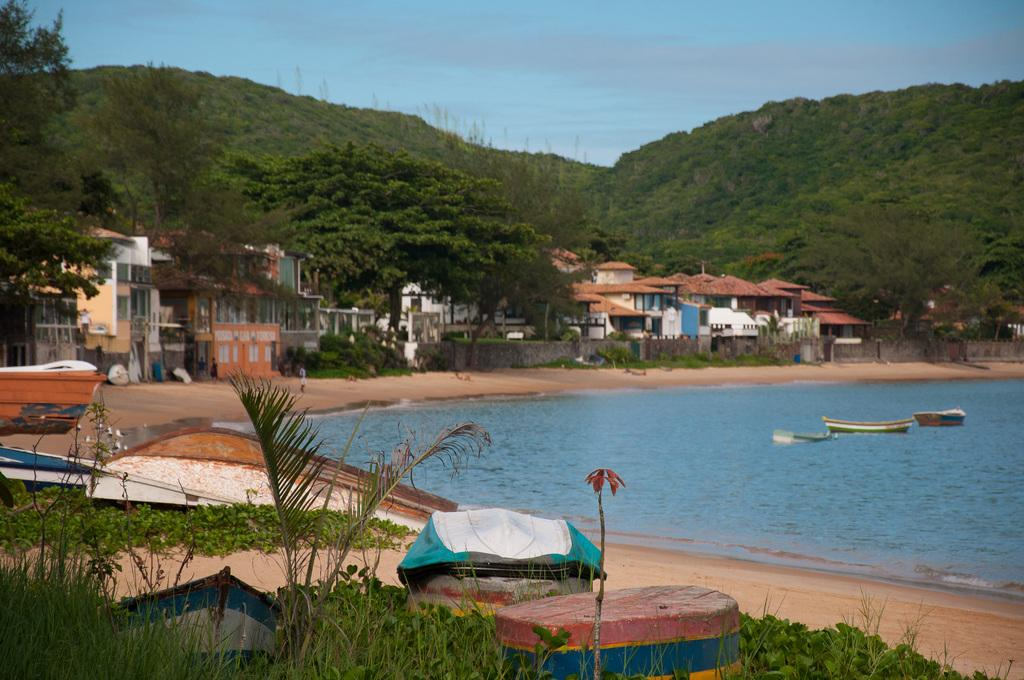What can be seen in the sky in the image? The sky with clouds is visible in the image. What type of structures are present in the image? There are buildings in the image. What type of barriers are present in the image? Walls are present in the image. What type of vegetation is visible in the image? Bushes are visible in the image. What type of transportation route is present in the image? A road is present in the image. What type of watercraft can be seen on the seashore in the image? Boats on the seashore are visible in the image. What type of watercraft can be seen on the water in the image? Boats on the water are visible in the image. How many passengers are on the observation deck in the image? There is no observation deck present in the image. What type of current is affecting the boats on the water in the image? There is no information about the current in the image; only the presence of boats on the water is mentioned. 